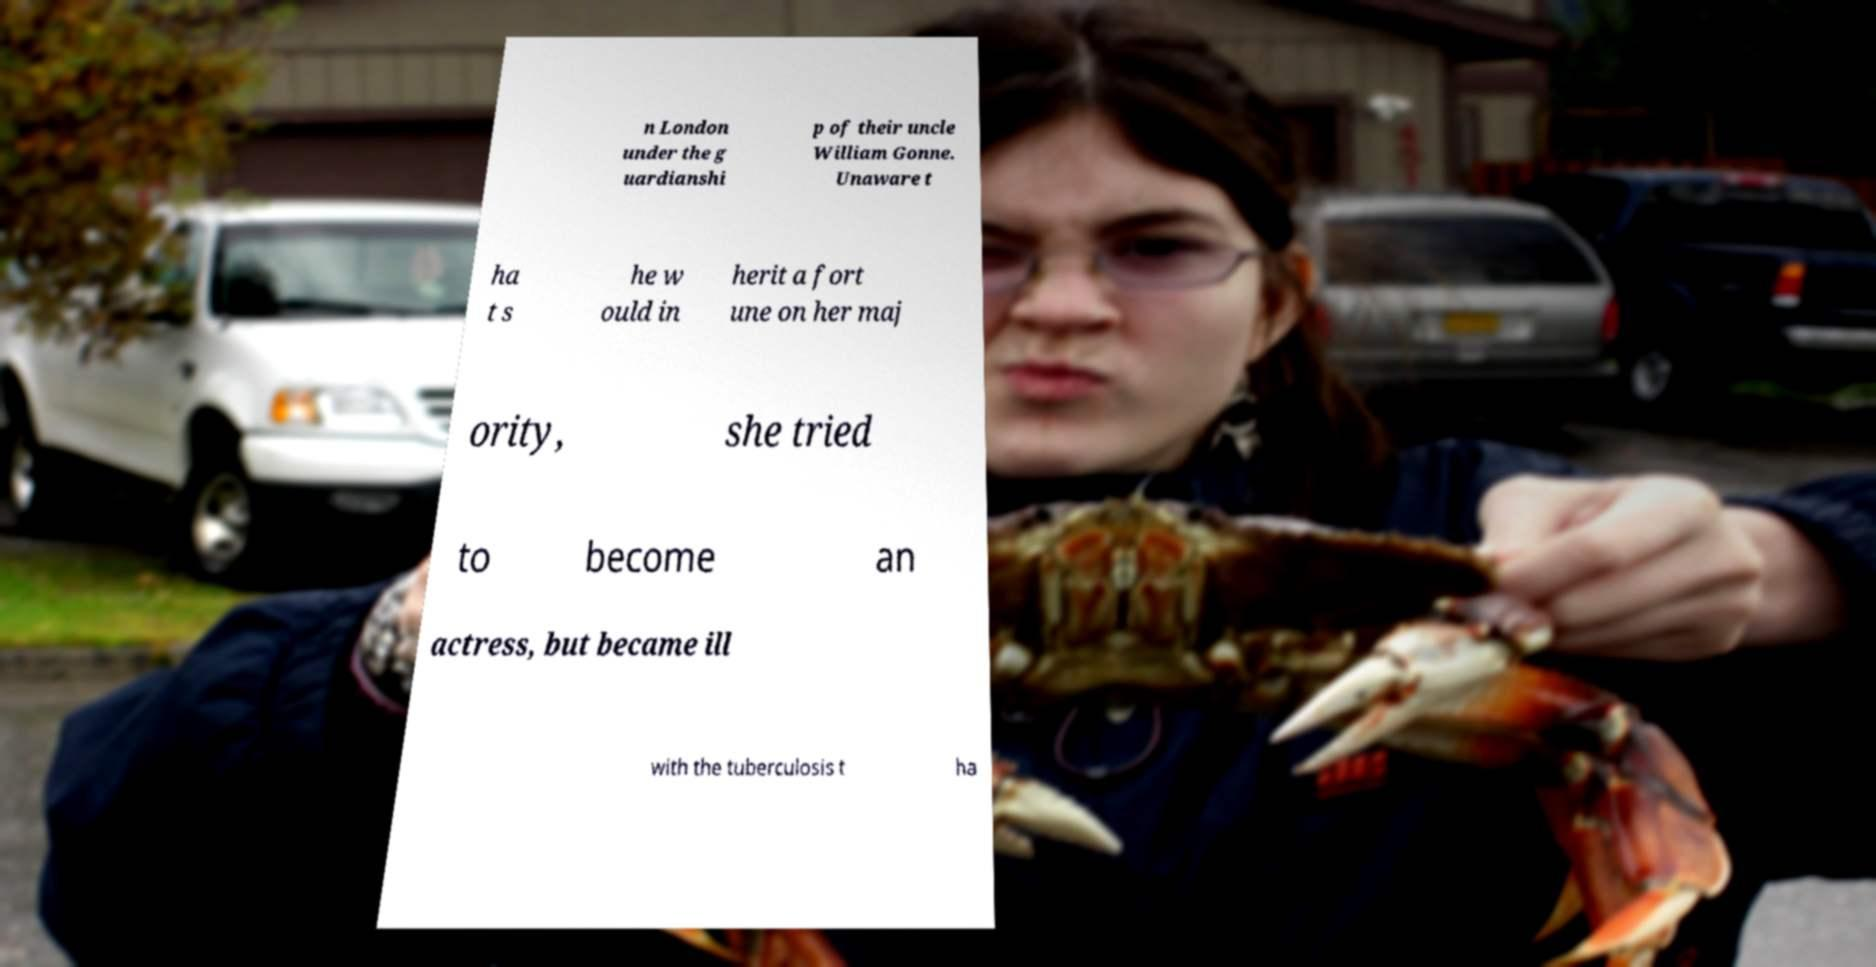Please read and relay the text visible in this image. What does it say? n London under the g uardianshi p of their uncle William Gonne. Unaware t ha t s he w ould in herit a fort une on her maj ority, she tried to become an actress, but became ill with the tuberculosis t ha 